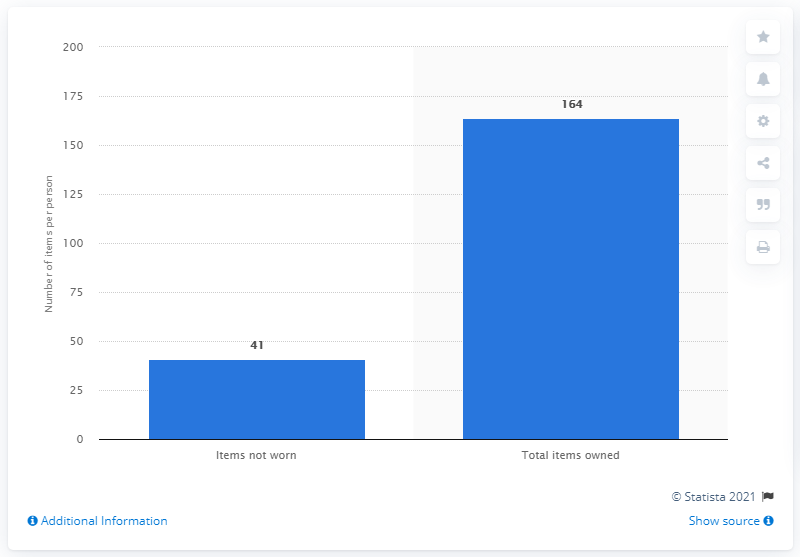Highlight a few significant elements in this photo. In the 1840s, it was estimated that the average woman in the United States owned 41 items of clothing that she did not wear. 